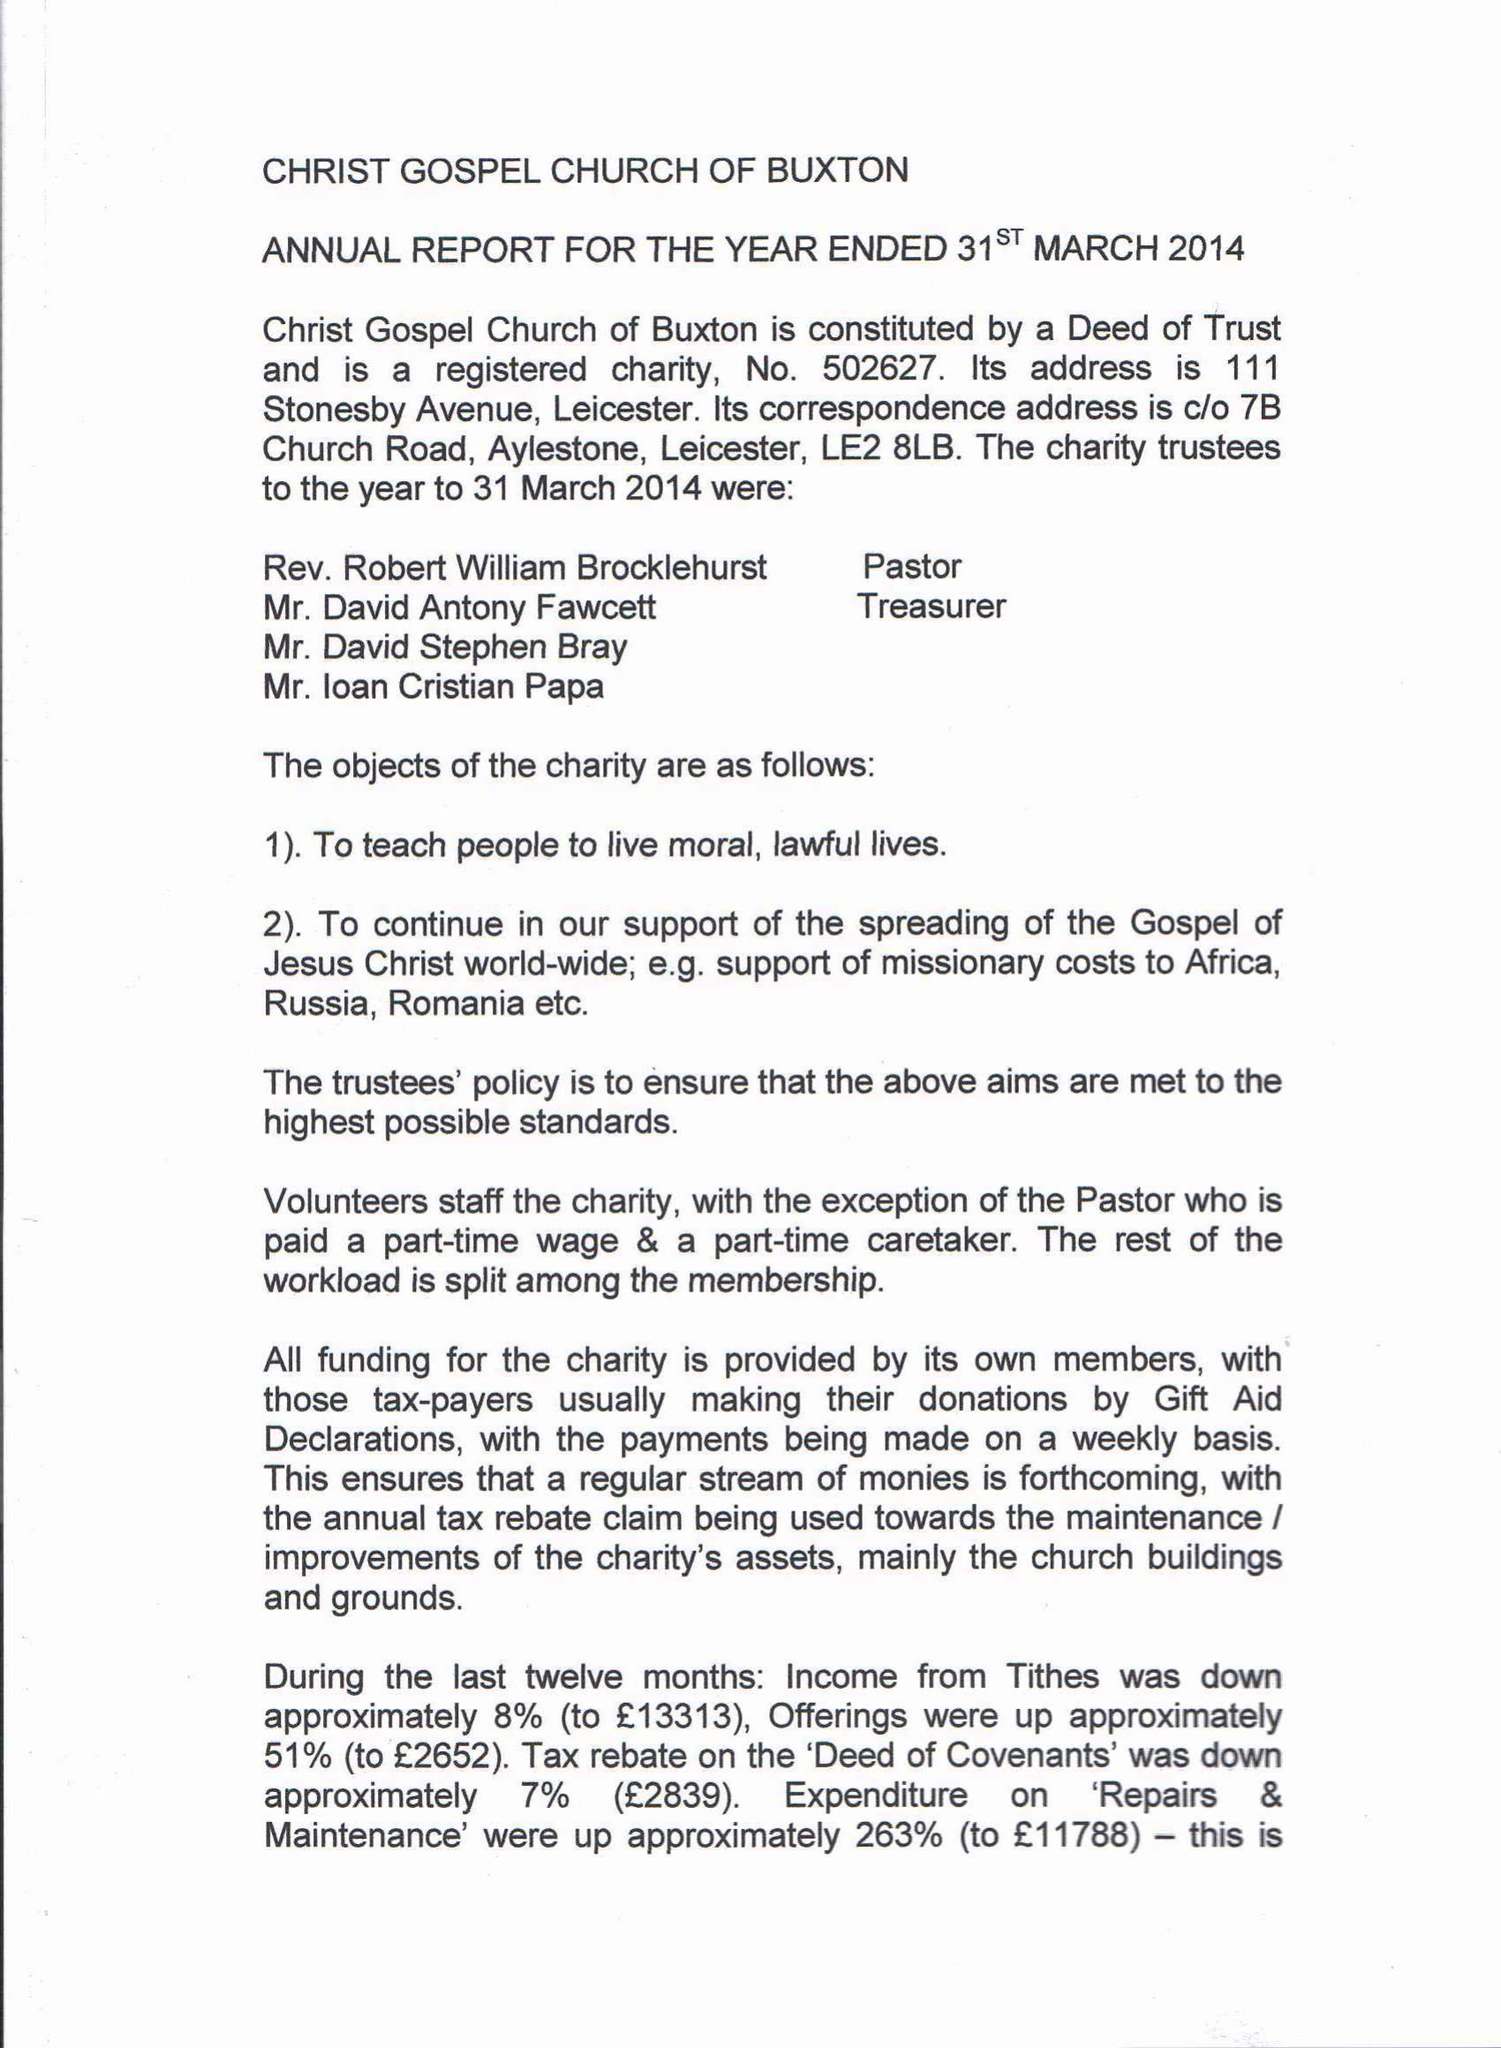What is the value for the spending_annually_in_british_pounds?
Answer the question using a single word or phrase. 39163.45 